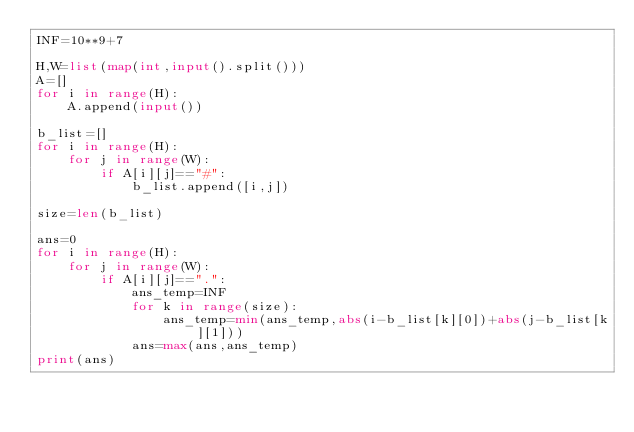Convert code to text. <code><loc_0><loc_0><loc_500><loc_500><_Python_>INF=10**9+7

H,W=list(map(int,input().split()))
A=[]
for i in range(H):
    A.append(input())
    
b_list=[]
for i in range(H):
    for j in range(W):
        if A[i][j]=="#":
            b_list.append([i,j])
            
size=len(b_list)

ans=0
for i in range(H):
    for j in range(W):
        if A[i][j]==".":
            ans_temp=INF
            for k in range(size):
                ans_temp=min(ans_temp,abs(i-b_list[k][0])+abs(j-b_list[k][1]))
            ans=max(ans,ans_temp)
print(ans)</code> 